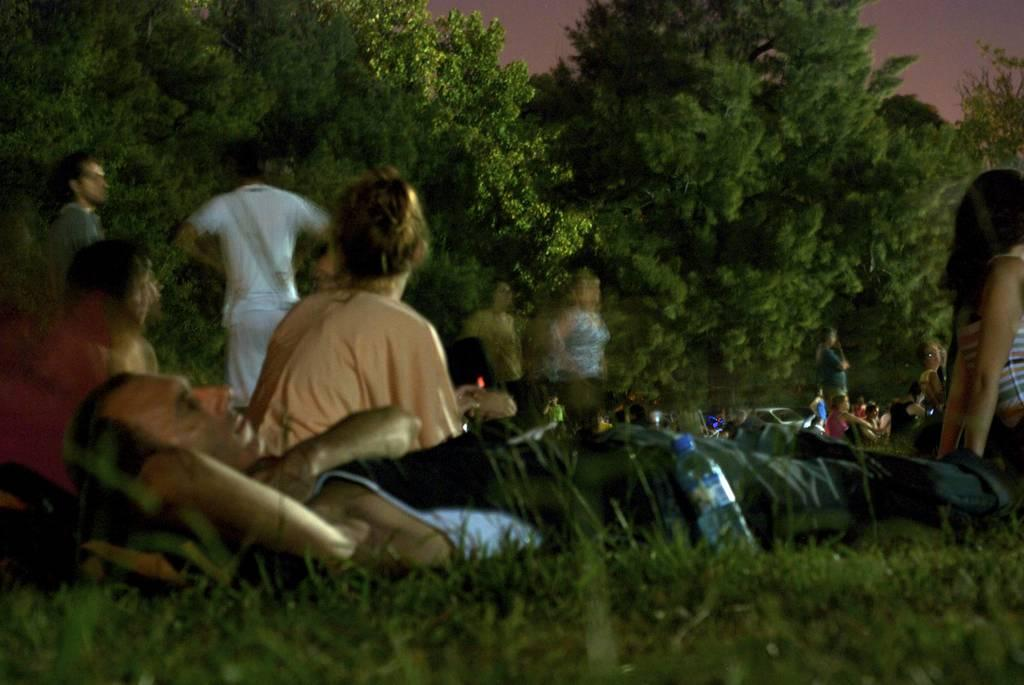What is the setting of the image? The setting of the image is a garden. What are the people in the foreground doing? There are people sitting in the garden. Can you describe the position of the man in the image? A man is lying down. What can be seen in the background of the image? In the background, there are people standing and trees visible. What type of art is being created by the people in the image? There is no indication in the image that the people are creating any art. 